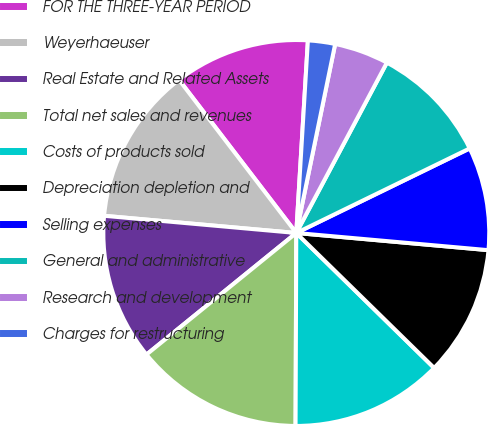Convert chart. <chart><loc_0><loc_0><loc_500><loc_500><pie_chart><fcel>FOR THE THREE-YEAR PERIOD<fcel>Weyerhaeuser<fcel>Real Estate and Related Assets<fcel>Total net sales and revenues<fcel>Costs of products sold<fcel>Depreciation depletion and<fcel>Selling expenses<fcel>General and administrative<fcel>Research and development<fcel>Charges for restructuring<nl><fcel>11.36%<fcel>13.18%<fcel>12.27%<fcel>14.09%<fcel>12.73%<fcel>10.91%<fcel>8.64%<fcel>10.0%<fcel>4.55%<fcel>2.27%<nl></chart> 